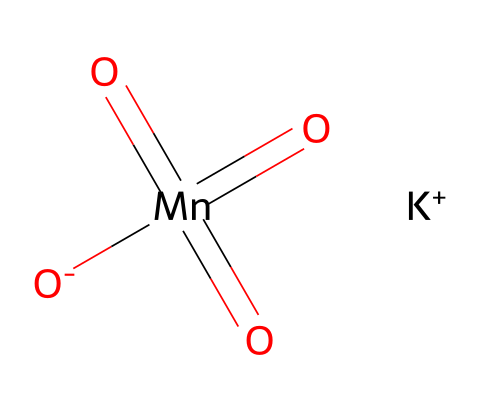What is the molecular formula of potassium permanganate? The molecular formula can be derived from the SMILES representation. It includes one potassium (K), one manganese (Mn), and four oxygen (O) atoms, corresponding to a total of one K, one Mn, and four O, leading to the formula KMnO4.
Answer: KMnO4 How many double bonds are present in the chemical structure? The SMILES shows the manganese (Mn) is surrounded by four oxygen atoms, with three of them represented as double-bonded through the use of '=(double bond)'. This indicates there are three double bonds in total.
Answer: 3 What is the oxidation state of manganese in potassium permanganate? In KMnO4, potassium is in +1 oxidation state, and each oxygen generally has a -2 state. The overall charge of the compound is neutral (0). By balancing the charges for Mn, we can set up the equation: +1 + x + 4(-2) = 0, leading to x (oxidation state of Mn) = +7.
Answer: +7 Which ion is responsible for the oxidizing properties of potassium permanganate? The oxidizing properties arise from the permanganate ion (MnO4-), specifically from the manganese in its high oxidation state of +7 that has a strong tendency to gain electrons.
Answer: permanganate ion How many atoms are present in the potassium permanganate molecule? To find the total number of atoms, we add the individual atoms represented in the molecular formula, which are 1 K, 1 Mn, and 4 O, thus totaling 6 atoms.
Answer: 6 What type of reactions can potassium permanganate facilitate due to its oxidizing nature? Potassium permanganate can facilitate oxidation-reduction reactions, where it can act as an oxidizing agent for organic compounds and in disinfection processes.
Answer: oxidation-reduction reactions 